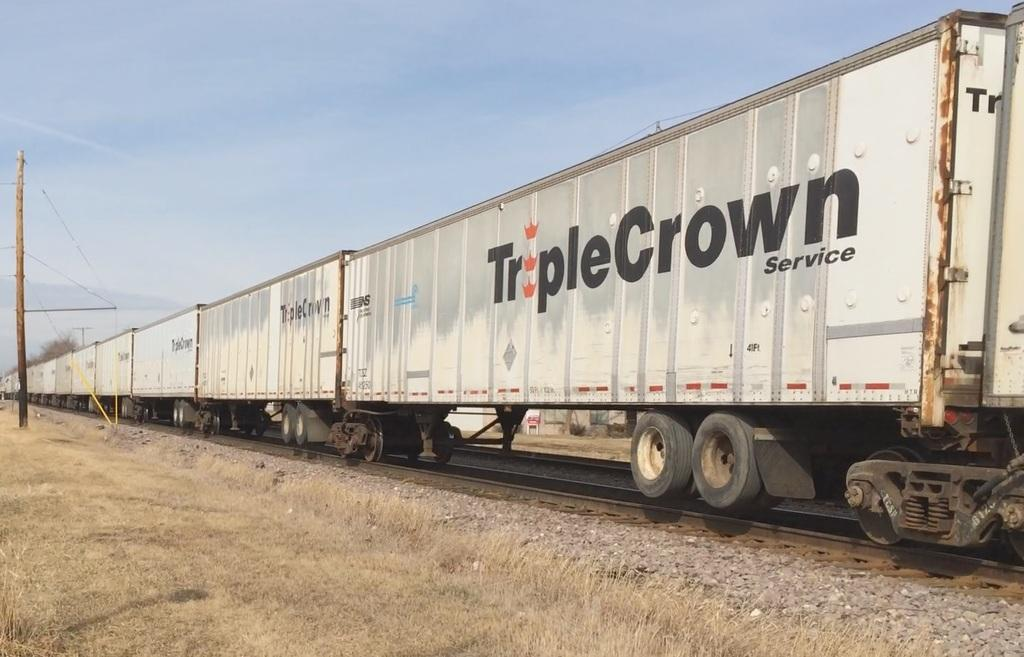<image>
Describe the image concisely. A cargo train is sitting on the train tracks with the box car logo printed on the side TRIPLECROWN. 